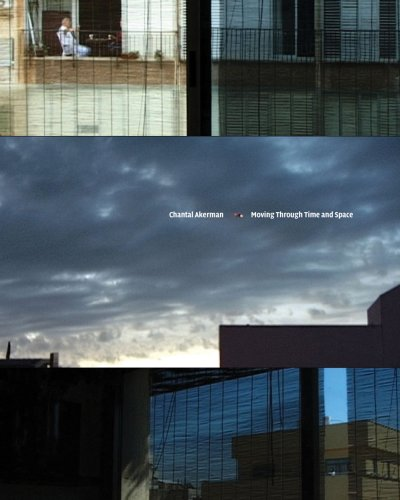What is the title of this book? The book is titled 'Chantal Akerman: Moving Through Time and Space,' which explores the profound impact Akerman had on film and art during her career. 